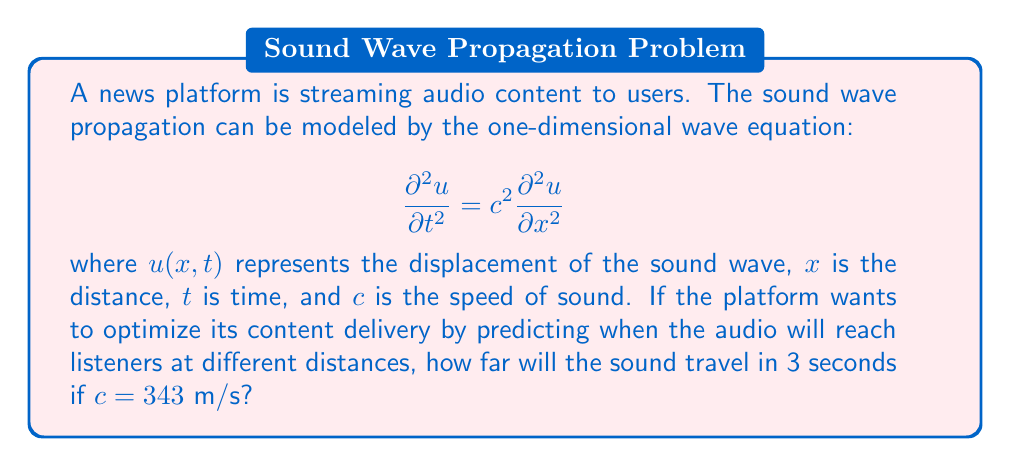Help me with this question. To solve this problem, we'll use the basic relationship between distance, speed, and time:

1) The formula relating distance $(d)$, speed $(c)$, and time $(t)$ is:
   
   $$d = c \cdot t$$

2) We are given:
   - Speed of sound, $c = 343$ m/s
   - Time, $t = 3$ seconds

3) Substituting these values into the formula:
   
   $$d = 343 \text{ m/s} \cdot 3 \text{ s}$$

4) Calculating:
   
   $$d = 1029 \text{ m}$$

Thus, in 3 seconds, the sound will travel 1029 meters.

This calculation helps the news platform predict audio delivery times to listeners at various distances, allowing for optimization of streaming delays and buffer times.
Answer: 1029 m 